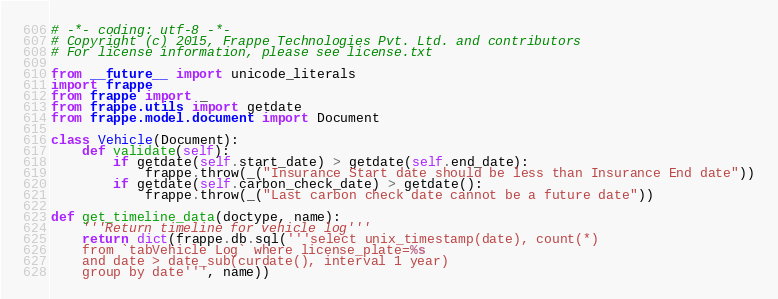Convert code to text. <code><loc_0><loc_0><loc_500><loc_500><_Python_># -*- coding: utf-8 -*-
# Copyright (c) 2015, Frappe Technologies Pvt. Ltd. and contributors
# For license information, please see license.txt

from __future__ import unicode_literals
import frappe
from frappe import _
from frappe.utils import getdate
from frappe.model.document import Document

class Vehicle(Document):
	def validate(self):
		if getdate(self.start_date) > getdate(self.end_date):
			frappe.throw(_("Insurance Start date should be less than Insurance End date"))
		if getdate(self.carbon_check_date) > getdate():
			frappe.throw(_("Last carbon check date cannot be a future date"))

def get_timeline_data(doctype, name):
	'''Return timeline for vehicle log'''
	return dict(frappe.db.sql('''select unix_timestamp(date), count(*)
	from `tabVehicle Log` where license_plate=%s
	and date > date_sub(curdate(), interval 1 year)
	group by date''', name))
</code> 